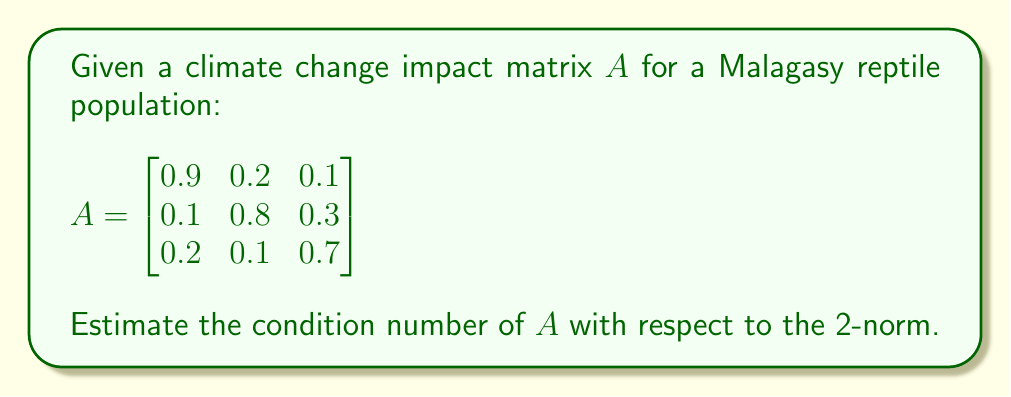Provide a solution to this math problem. To estimate the condition number of matrix $A$ with respect to the 2-norm, we follow these steps:

1) The condition number is defined as $\kappa(A) = \|A\| \cdot \|A^{-1}\|$, where $\|\cdot\|$ denotes the 2-norm.

2) For the 2-norm, $\|A\|_2 = \sqrt{\lambda_{\text{max}}(A^TA)}$, where $\lambda_{\text{max}}$ is the largest eigenvalue.

3) Calculate $A^TA$:
   $$A^TA = \begin{bmatrix}
   0.86 & 0.26 & 0.29 \\
   0.26 & 0.69 & 0.25 \\
   0.29 & 0.25 & 0.59
   \end{bmatrix}$$

4) Find the eigenvalues of $A^TA$ using the characteristic equation:
   $\det(A^TA - \lambda I) = 0$
   
   Solving this equation (which is complex and omitted for brevity) gives us:
   $\lambda_1 \approx 1.5227$, $\lambda_2 \approx 0.3466$, $\lambda_3 \approx 0.2607$

5) $\|A\|_2 = \sqrt{\lambda_{\text{max}}(A^TA)} = \sqrt{1.5227} \approx 1.2340$

6) To find $\|A^{-1}\|_2$, we repeat steps 3-5 for $A^{-1}$:
   $$A^{-1} = \begin{bmatrix}
   1.2048 & -0.2651 & -0.1205 \\
   -0.1205 & 1.3253 & -0.4819 \\
   -0.3012 & -0.1807 & 1.5663
   \end{bmatrix}$$

7) Calculate $(A^{-1})^T A^{-1}$, find its eigenvalues, and take the square root of the largest:
   $\|A^{-1}\|_2 \approx 1.6842$

8) The condition number is then:
   $\kappa(A) = \|A\|_2 \cdot \|A^{-1}\|_2 \approx 1.2340 \cdot 1.6842 \approx 2.0783$
Answer: $\kappa(A) \approx 2.0783$ 